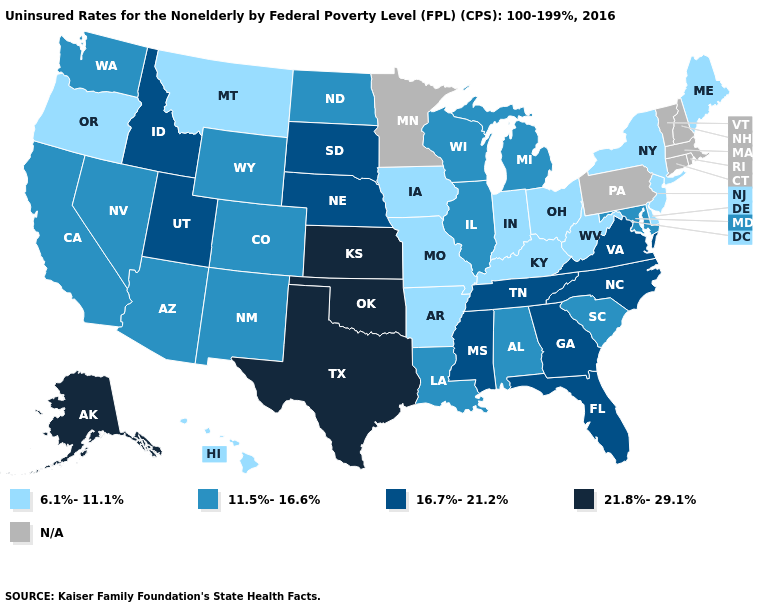What is the value of Massachusetts?
Short answer required. N/A. Does Florida have the lowest value in the USA?
Keep it brief. No. What is the value of Kentucky?
Be succinct. 6.1%-11.1%. Name the states that have a value in the range 16.7%-21.2%?
Answer briefly. Florida, Georgia, Idaho, Mississippi, Nebraska, North Carolina, South Dakota, Tennessee, Utah, Virginia. Does Kentucky have the highest value in the South?
Keep it brief. No. Among the states that border Washington , does Oregon have the highest value?
Keep it brief. No. Does West Virginia have the lowest value in the USA?
Write a very short answer. Yes. Which states have the lowest value in the USA?
Answer briefly. Arkansas, Delaware, Hawaii, Indiana, Iowa, Kentucky, Maine, Missouri, Montana, New Jersey, New York, Ohio, Oregon, West Virginia. What is the value of Nebraska?
Quick response, please. 16.7%-21.2%. What is the value of Indiana?
Keep it brief. 6.1%-11.1%. Among the states that border Wyoming , which have the highest value?
Quick response, please. Idaho, Nebraska, South Dakota, Utah. Does Nebraska have the lowest value in the MidWest?
Concise answer only. No. Name the states that have a value in the range 11.5%-16.6%?
Concise answer only. Alabama, Arizona, California, Colorado, Illinois, Louisiana, Maryland, Michigan, Nevada, New Mexico, North Dakota, South Carolina, Washington, Wisconsin, Wyoming. What is the value of Colorado?
Quick response, please. 11.5%-16.6%. Among the states that border Arizona , which have the lowest value?
Be succinct. California, Colorado, Nevada, New Mexico. 